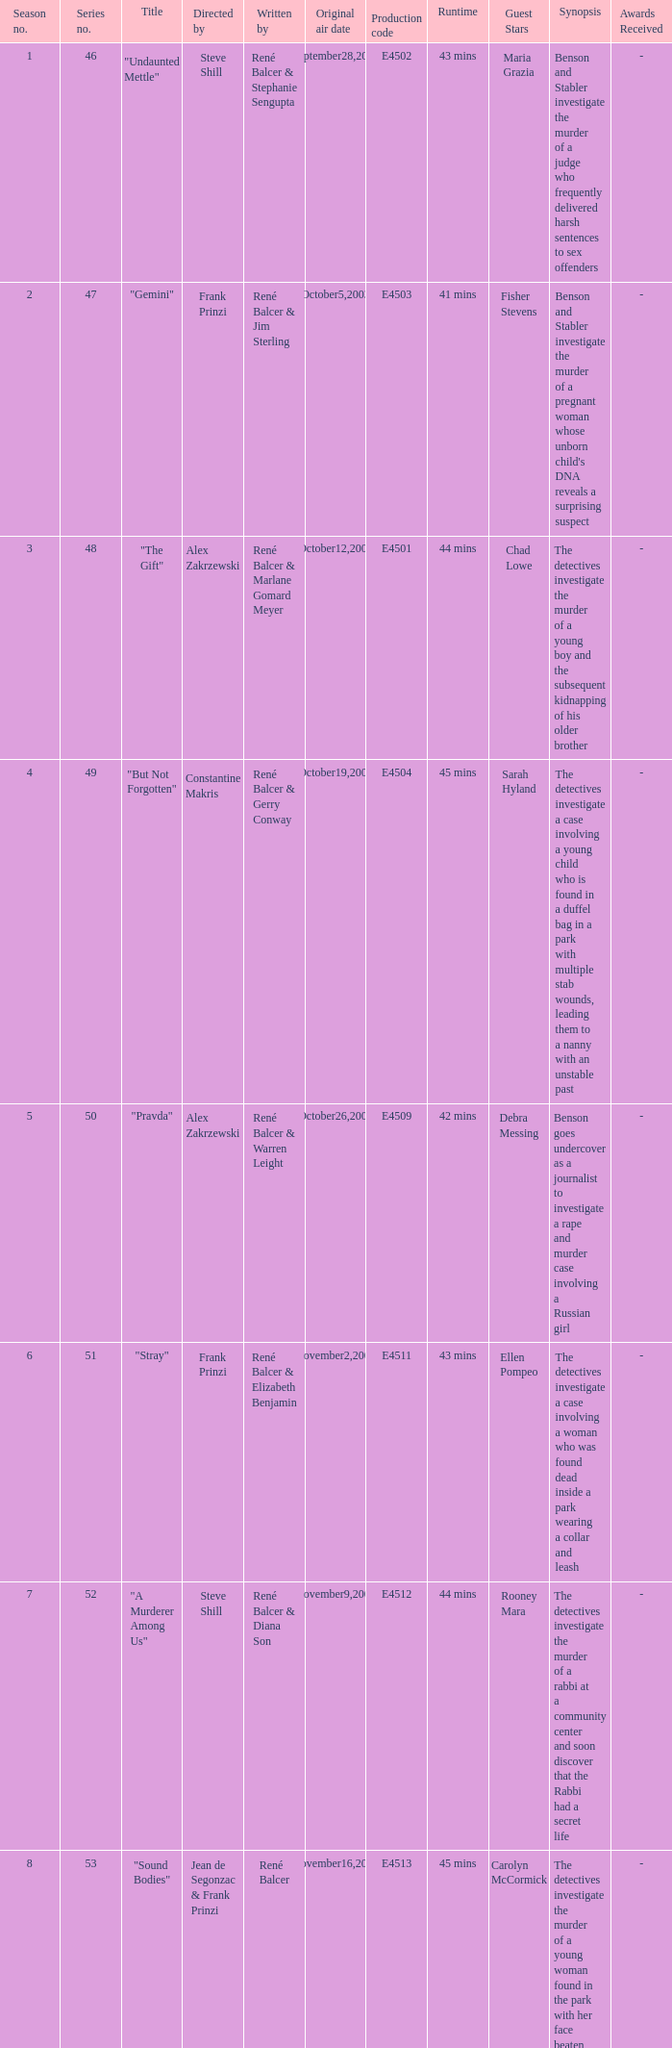What episode number in the season is titled "stray"? 6.0. 